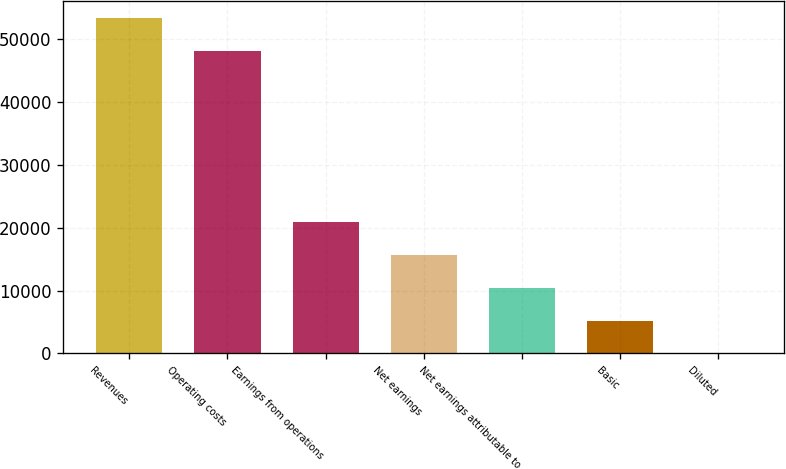<chart> <loc_0><loc_0><loc_500><loc_500><bar_chart><fcel>Revenues<fcel>Operating costs<fcel>Earnings from operations<fcel>Net earnings<fcel>Net earnings attributable to<fcel>Basic<fcel>Diluted<nl><fcel>53289.7<fcel>48084<fcel>20826.6<fcel>15620.9<fcel>10415.1<fcel>5209.39<fcel>3.65<nl></chart> 